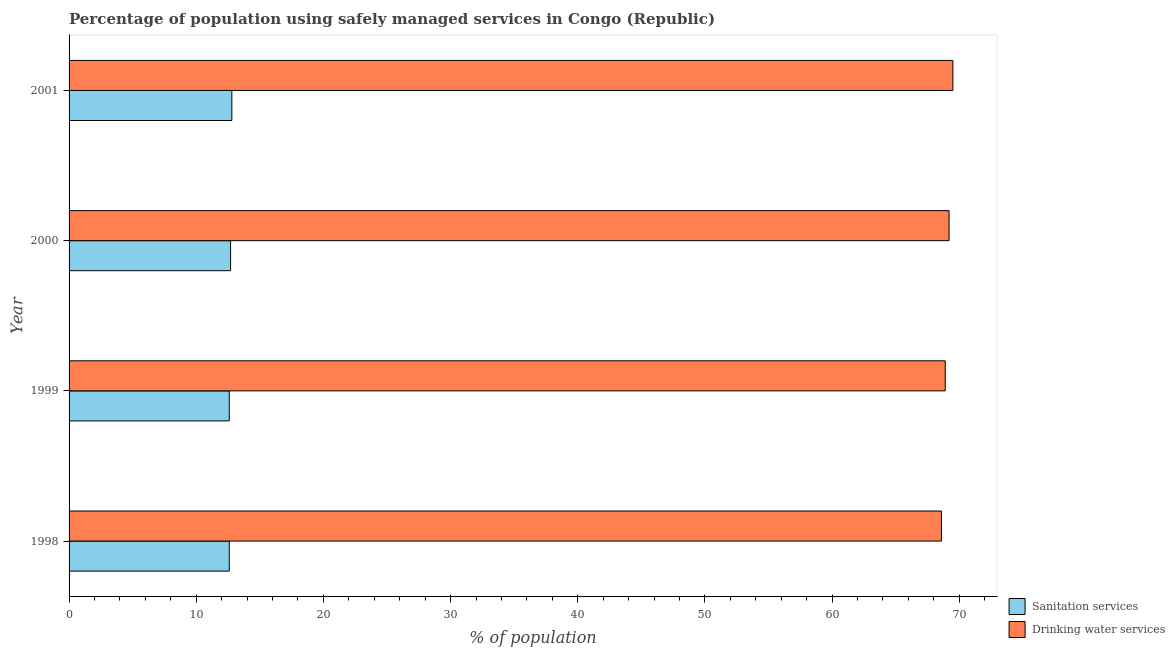How many different coloured bars are there?
Your answer should be compact. 2. Are the number of bars per tick equal to the number of legend labels?
Offer a very short reply. Yes. Are the number of bars on each tick of the Y-axis equal?
Ensure brevity in your answer.  Yes. How many bars are there on the 4th tick from the top?
Provide a short and direct response. 2. What is the percentage of population who used drinking water services in 1999?
Your response must be concise. 68.9. Across all years, what is the maximum percentage of population who used drinking water services?
Give a very brief answer. 69.5. Across all years, what is the minimum percentage of population who used drinking water services?
Offer a terse response. 68.6. In which year was the percentage of population who used drinking water services maximum?
Provide a short and direct response. 2001. What is the total percentage of population who used drinking water services in the graph?
Your answer should be compact. 276.2. What is the difference between the percentage of population who used drinking water services in 1999 and the percentage of population who used sanitation services in 1998?
Your answer should be compact. 56.3. What is the average percentage of population who used drinking water services per year?
Your answer should be compact. 69.05. In the year 2001, what is the difference between the percentage of population who used sanitation services and percentage of population who used drinking water services?
Provide a succinct answer. -56.7. In how many years, is the percentage of population who used drinking water services greater than 26 %?
Keep it short and to the point. 4. Is the sum of the percentage of population who used sanitation services in 2000 and 2001 greater than the maximum percentage of population who used drinking water services across all years?
Provide a short and direct response. No. What does the 2nd bar from the top in 1998 represents?
Offer a terse response. Sanitation services. What does the 1st bar from the bottom in 2000 represents?
Offer a very short reply. Sanitation services. How many years are there in the graph?
Offer a very short reply. 4. Does the graph contain any zero values?
Ensure brevity in your answer.  No. Where does the legend appear in the graph?
Offer a terse response. Bottom right. How many legend labels are there?
Provide a short and direct response. 2. What is the title of the graph?
Offer a terse response. Percentage of population using safely managed services in Congo (Republic). What is the label or title of the X-axis?
Keep it short and to the point. % of population. What is the label or title of the Y-axis?
Keep it short and to the point. Year. What is the % of population of Drinking water services in 1998?
Offer a very short reply. 68.6. What is the % of population in Sanitation services in 1999?
Provide a succinct answer. 12.6. What is the % of population of Drinking water services in 1999?
Offer a terse response. 68.9. What is the % of population of Drinking water services in 2000?
Offer a terse response. 69.2. What is the % of population of Sanitation services in 2001?
Provide a succinct answer. 12.8. What is the % of population in Drinking water services in 2001?
Ensure brevity in your answer.  69.5. Across all years, what is the maximum % of population in Sanitation services?
Offer a terse response. 12.8. Across all years, what is the maximum % of population in Drinking water services?
Your response must be concise. 69.5. Across all years, what is the minimum % of population in Sanitation services?
Provide a short and direct response. 12.6. Across all years, what is the minimum % of population of Drinking water services?
Provide a short and direct response. 68.6. What is the total % of population of Sanitation services in the graph?
Your response must be concise. 50.7. What is the total % of population of Drinking water services in the graph?
Provide a succinct answer. 276.2. What is the difference between the % of population of Sanitation services in 1998 and that in 1999?
Your answer should be compact. 0. What is the difference between the % of population in Drinking water services in 1998 and that in 2000?
Your response must be concise. -0.6. What is the difference between the % of population in Sanitation services in 1998 and that in 2001?
Offer a very short reply. -0.2. What is the difference between the % of population in Drinking water services in 1998 and that in 2001?
Make the answer very short. -0.9. What is the difference between the % of population in Sanitation services in 1999 and that in 2000?
Keep it short and to the point. -0.1. What is the difference between the % of population in Drinking water services in 1999 and that in 2000?
Provide a short and direct response. -0.3. What is the difference between the % of population of Sanitation services in 1999 and that in 2001?
Provide a succinct answer. -0.2. What is the difference between the % of population of Drinking water services in 1999 and that in 2001?
Give a very brief answer. -0.6. What is the difference between the % of population in Sanitation services in 1998 and the % of population in Drinking water services in 1999?
Ensure brevity in your answer.  -56.3. What is the difference between the % of population of Sanitation services in 1998 and the % of population of Drinking water services in 2000?
Provide a short and direct response. -56.6. What is the difference between the % of population in Sanitation services in 1998 and the % of population in Drinking water services in 2001?
Your response must be concise. -56.9. What is the difference between the % of population in Sanitation services in 1999 and the % of population in Drinking water services in 2000?
Keep it short and to the point. -56.6. What is the difference between the % of population of Sanitation services in 1999 and the % of population of Drinking water services in 2001?
Provide a short and direct response. -56.9. What is the difference between the % of population in Sanitation services in 2000 and the % of population in Drinking water services in 2001?
Offer a terse response. -56.8. What is the average % of population in Sanitation services per year?
Your answer should be compact. 12.68. What is the average % of population of Drinking water services per year?
Provide a succinct answer. 69.05. In the year 1998, what is the difference between the % of population of Sanitation services and % of population of Drinking water services?
Ensure brevity in your answer.  -56. In the year 1999, what is the difference between the % of population in Sanitation services and % of population in Drinking water services?
Provide a succinct answer. -56.3. In the year 2000, what is the difference between the % of population of Sanitation services and % of population of Drinking water services?
Offer a terse response. -56.5. In the year 2001, what is the difference between the % of population in Sanitation services and % of population in Drinking water services?
Make the answer very short. -56.7. What is the ratio of the % of population in Sanitation services in 1998 to that in 2000?
Provide a succinct answer. 0.99. What is the ratio of the % of population of Drinking water services in 1998 to that in 2000?
Keep it short and to the point. 0.99. What is the ratio of the % of population of Sanitation services in 1998 to that in 2001?
Ensure brevity in your answer.  0.98. What is the ratio of the % of population of Drinking water services in 1998 to that in 2001?
Offer a very short reply. 0.99. What is the ratio of the % of population in Sanitation services in 1999 to that in 2000?
Provide a short and direct response. 0.99. What is the ratio of the % of population of Sanitation services in 1999 to that in 2001?
Make the answer very short. 0.98. What is the ratio of the % of population of Sanitation services in 2000 to that in 2001?
Your response must be concise. 0.99. What is the ratio of the % of population in Drinking water services in 2000 to that in 2001?
Provide a succinct answer. 1. What is the difference between the highest and the second highest % of population of Drinking water services?
Make the answer very short. 0.3. What is the difference between the highest and the lowest % of population of Sanitation services?
Make the answer very short. 0.2. 